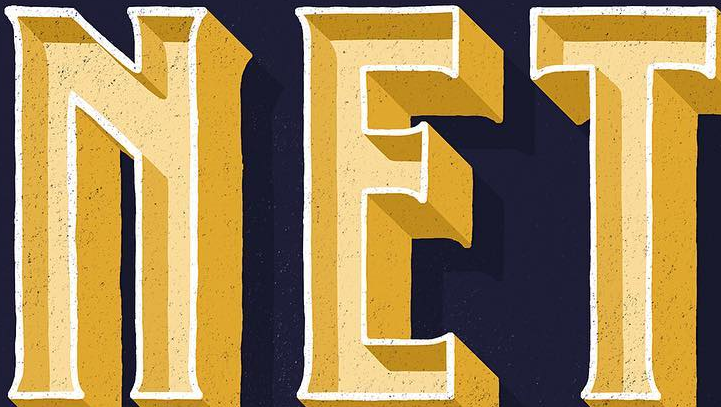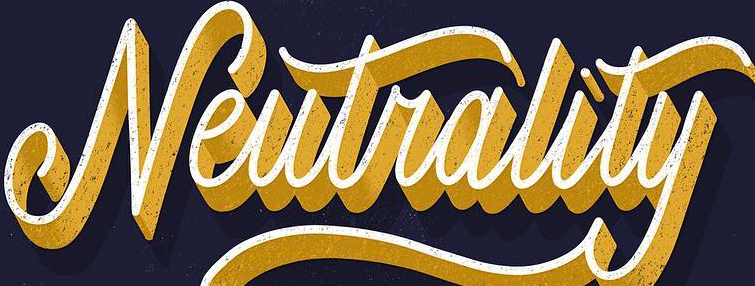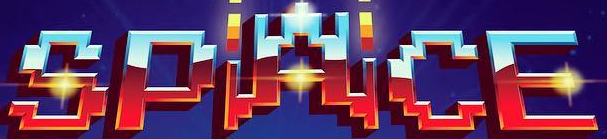What words are shown in these images in order, separated by a semicolon? NET; Neutrality; SPACE 